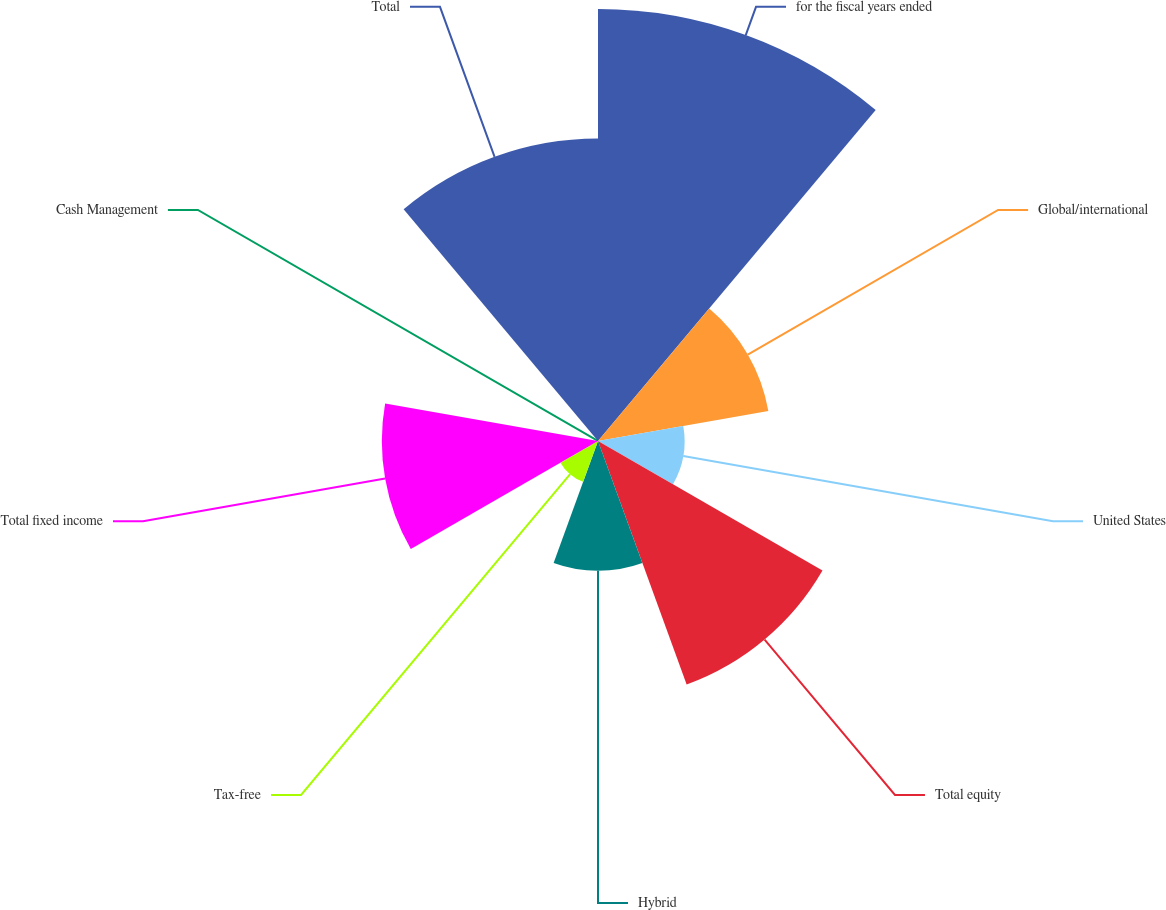Convert chart. <chart><loc_0><loc_0><loc_500><loc_500><pie_chart><fcel>for the fiscal years ended<fcel>Global/international<fcel>United States<fcel>Total equity<fcel>Hybrid<fcel>Tax-free<fcel>Total fixed income<fcel>Cash Management<fcel>Total<nl><fcel>26.3%<fcel>10.53%<fcel>5.27%<fcel>15.78%<fcel>7.9%<fcel>2.64%<fcel>13.16%<fcel>0.01%<fcel>18.41%<nl></chart> 